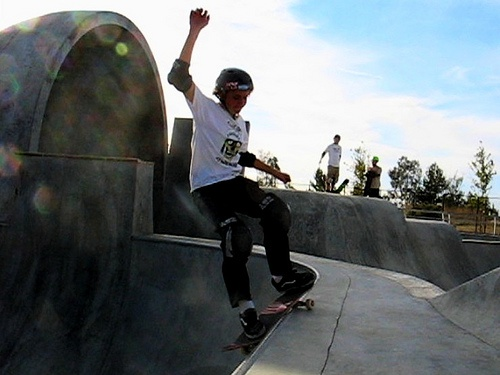Describe the objects in this image and their specific colors. I can see people in white, black, and gray tones, skateboard in white, black, and gray tones, people in white, darkgray, black, and gray tones, people in white, black, gray, and darkgreen tones, and skateboard in white, black, ivory, and gray tones in this image. 